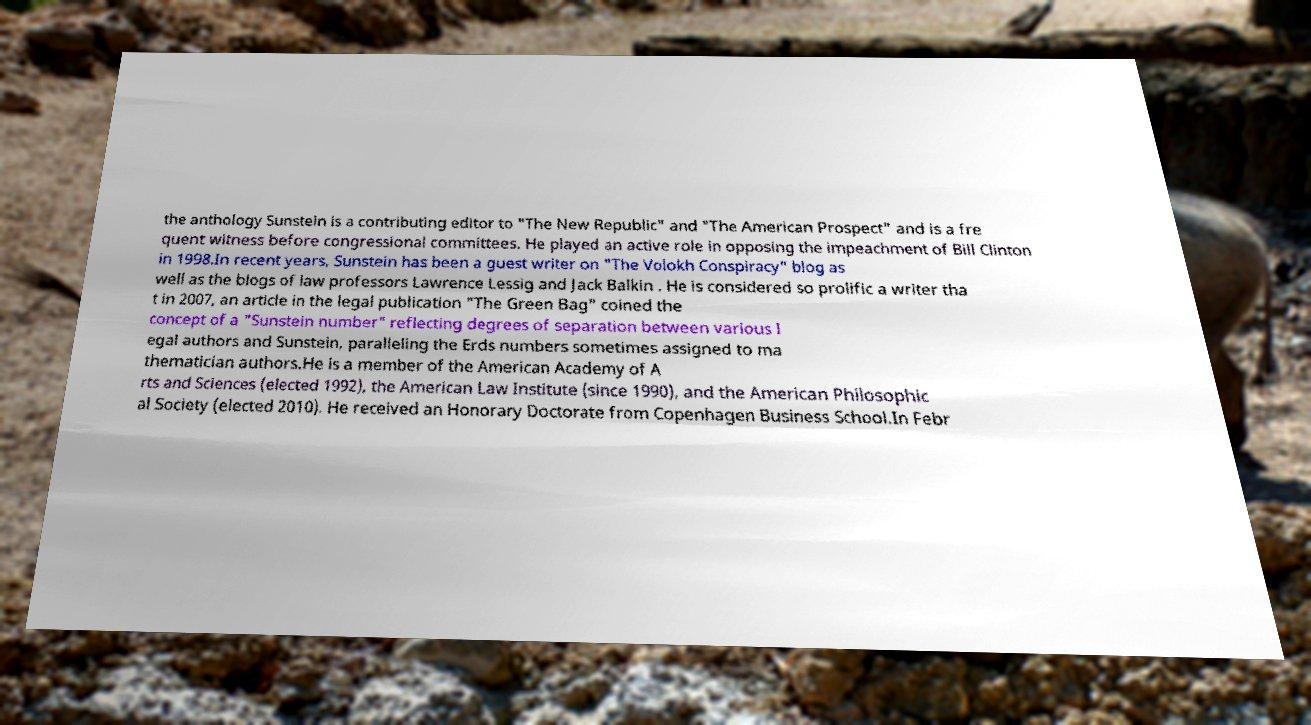Can you read and provide the text displayed in the image?This photo seems to have some interesting text. Can you extract and type it out for me? the anthology Sunstein is a contributing editor to "The New Republic" and "The American Prospect" and is a fre quent witness before congressional committees. He played an active role in opposing the impeachment of Bill Clinton in 1998.In recent years, Sunstein has been a guest writer on "The Volokh Conspiracy" blog as well as the blogs of law professors Lawrence Lessig and Jack Balkin . He is considered so prolific a writer tha t in 2007, an article in the legal publication "The Green Bag" coined the concept of a "Sunstein number" reflecting degrees of separation between various l egal authors and Sunstein, paralleling the Erds numbers sometimes assigned to ma thematician authors.He is a member of the American Academy of A rts and Sciences (elected 1992), the American Law Institute (since 1990), and the American Philosophic al Society (elected 2010). He received an Honorary Doctorate from Copenhagen Business School.In Febr 